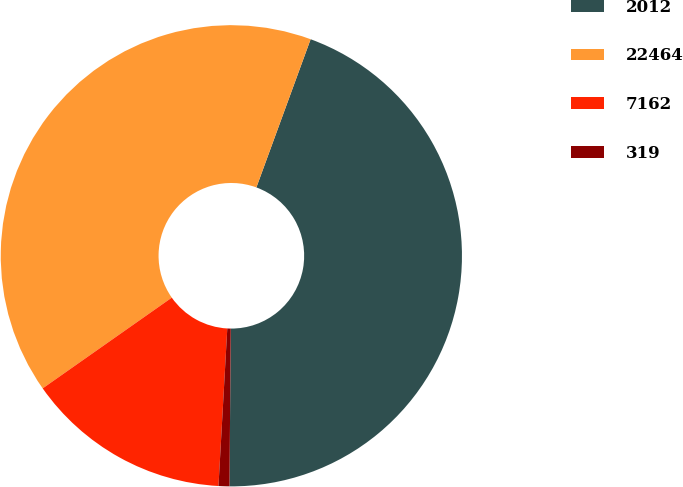<chart> <loc_0><loc_0><loc_500><loc_500><pie_chart><fcel>2012<fcel>22464<fcel>7162<fcel>319<nl><fcel>44.54%<fcel>40.33%<fcel>14.36%<fcel>0.76%<nl></chart> 